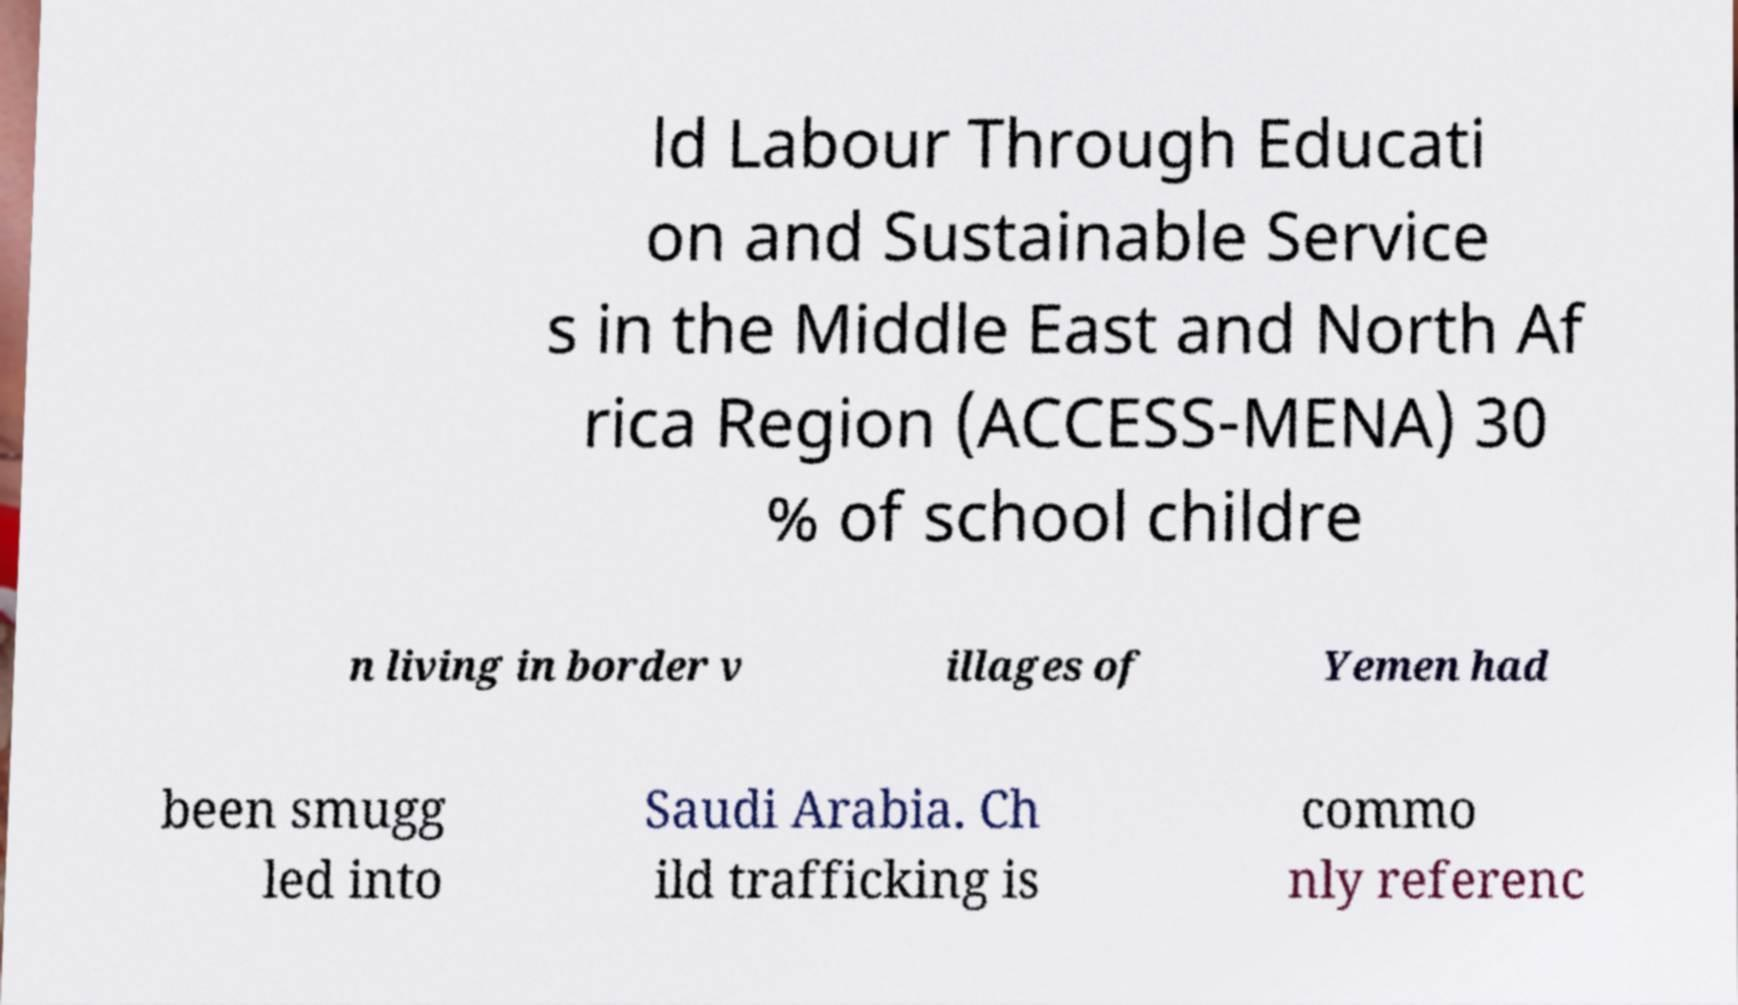Could you extract and type out the text from this image? ld Labour Through Educati on and Sustainable Service s in the Middle East and North Af rica Region (ACCESS-MENA) 30 % of school childre n living in border v illages of Yemen had been smugg led into Saudi Arabia. Ch ild trafficking is commo nly referenc 